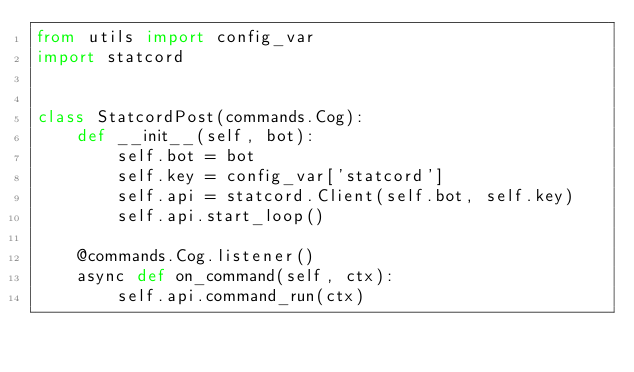Convert code to text. <code><loc_0><loc_0><loc_500><loc_500><_Python_>from utils import config_var
import statcord


class StatcordPost(commands.Cog):
    def __init__(self, bot):
        self.bot = bot
        self.key = config_var['statcord']
        self.api = statcord.Client(self.bot, self.key)
        self.api.start_loop()

    @commands.Cog.listener()
    async def on_command(self, ctx):
        self.api.command_run(ctx)</code> 